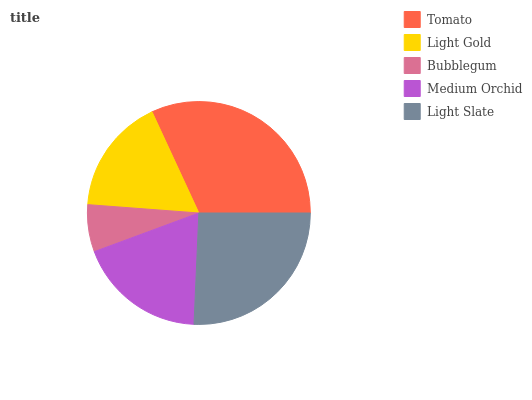Is Bubblegum the minimum?
Answer yes or no. Yes. Is Tomato the maximum?
Answer yes or no. Yes. Is Light Gold the minimum?
Answer yes or no. No. Is Light Gold the maximum?
Answer yes or no. No. Is Tomato greater than Light Gold?
Answer yes or no. Yes. Is Light Gold less than Tomato?
Answer yes or no. Yes. Is Light Gold greater than Tomato?
Answer yes or no. No. Is Tomato less than Light Gold?
Answer yes or no. No. Is Medium Orchid the high median?
Answer yes or no. Yes. Is Medium Orchid the low median?
Answer yes or no. Yes. Is Bubblegum the high median?
Answer yes or no. No. Is Bubblegum the low median?
Answer yes or no. No. 